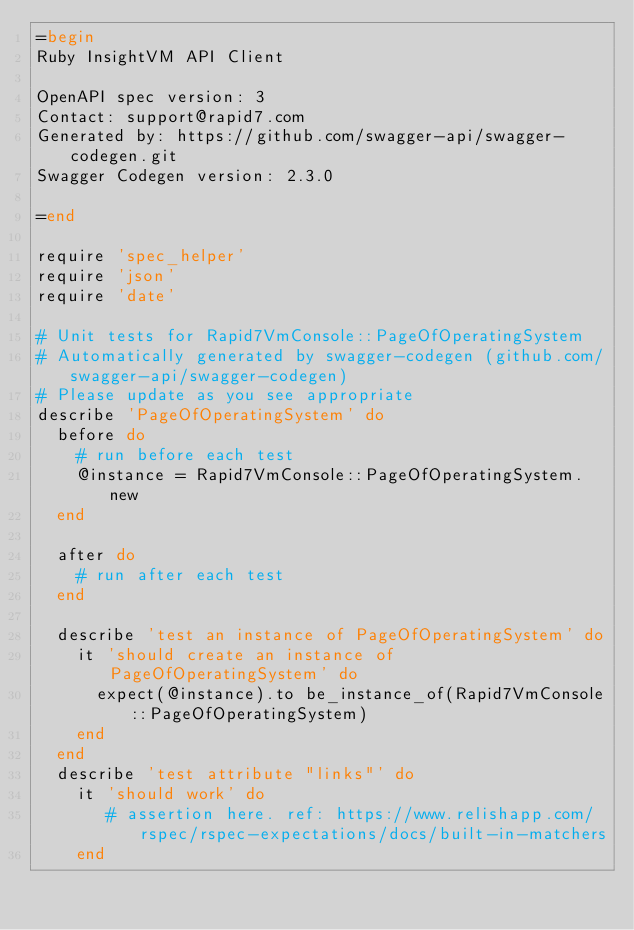<code> <loc_0><loc_0><loc_500><loc_500><_Ruby_>=begin
Ruby InsightVM API Client

OpenAPI spec version: 3
Contact: support@rapid7.com
Generated by: https://github.com/swagger-api/swagger-codegen.git
Swagger Codegen version: 2.3.0

=end

require 'spec_helper'
require 'json'
require 'date'

# Unit tests for Rapid7VmConsole::PageOfOperatingSystem
# Automatically generated by swagger-codegen (github.com/swagger-api/swagger-codegen)
# Please update as you see appropriate
describe 'PageOfOperatingSystem' do
  before do
    # run before each test
    @instance = Rapid7VmConsole::PageOfOperatingSystem.new
  end

  after do
    # run after each test
  end

  describe 'test an instance of PageOfOperatingSystem' do
    it 'should create an instance of PageOfOperatingSystem' do
      expect(@instance).to be_instance_of(Rapid7VmConsole::PageOfOperatingSystem)
    end
  end
  describe 'test attribute "links"' do
    it 'should work' do
       # assertion here. ref: https://www.relishapp.com/rspec/rspec-expectations/docs/built-in-matchers
    end</code> 